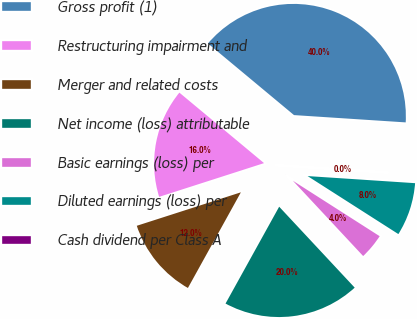<chart> <loc_0><loc_0><loc_500><loc_500><pie_chart><fcel>Gross profit (1)<fcel>Restructuring impairment and<fcel>Merger and related costs<fcel>Net income (loss) attributable<fcel>Basic earnings (loss) per<fcel>Diluted earnings (loss) per<fcel>Cash dividend per Class A<nl><fcel>39.99%<fcel>16.0%<fcel>12.0%<fcel>20.0%<fcel>4.0%<fcel>8.0%<fcel>0.01%<nl></chart> 